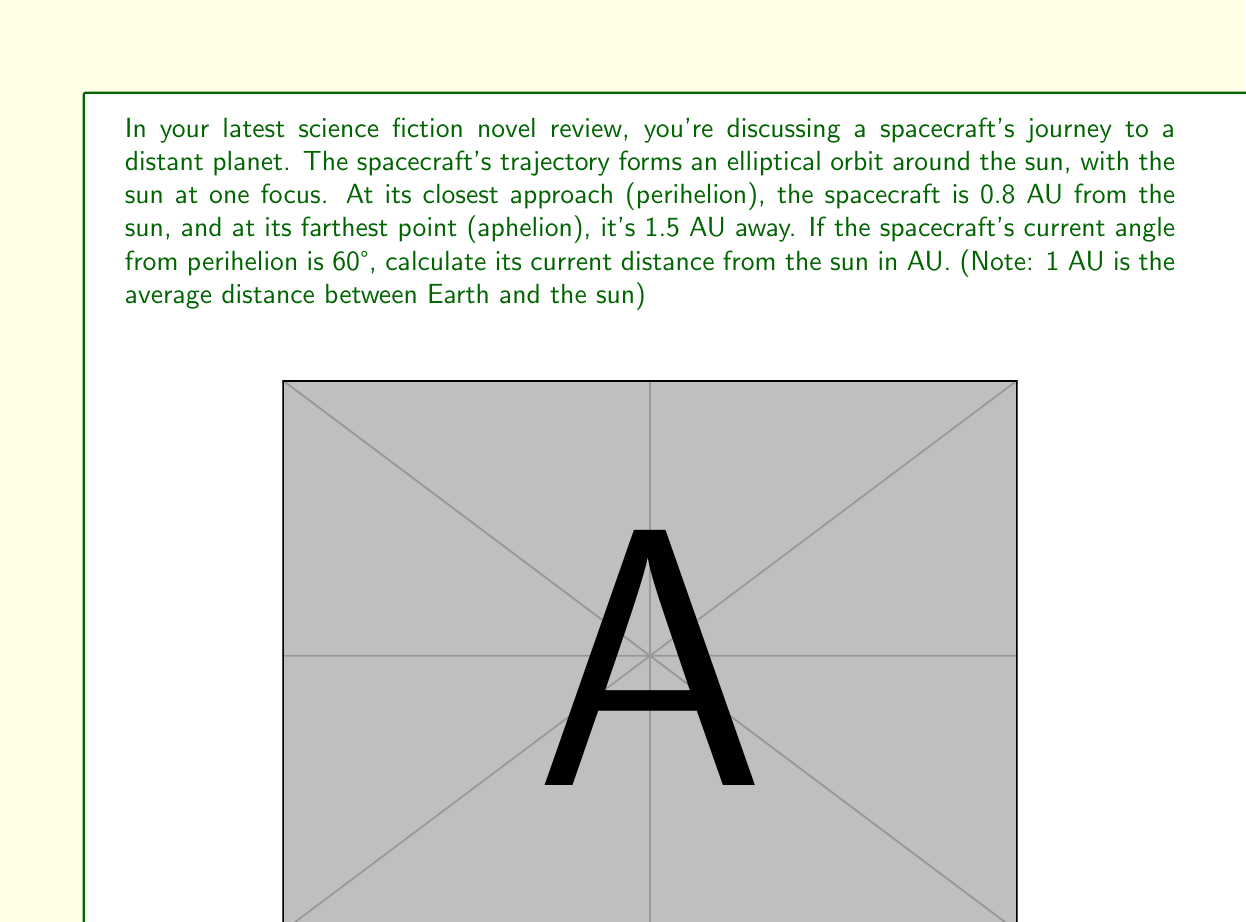Could you help me with this problem? To solve this problem, we'll use the polar equation of an ellipse:

$$r = \frac{a(1-e^2)}{1 + e \cos(\theta)}$$

Where:
$r$ is the distance from the focus (sun) to a point on the ellipse
$a$ is the semi-major axis
$e$ is the eccentricity
$\theta$ is the angle from perihelion

Step 1: Calculate the semi-major axis $(a)$
The semi-major axis is the average of the perihelion and aphelion distances:

$$a = \frac{0.8 + 1.5}{2} = 1.15 \text{ AU}$$

Step 2: Calculate the eccentricity $(e)$
The eccentricity can be found using the perihelion distance $(q)$ and the semi-major axis:

$$e = 1 - \frac{q}{a} = 1 - \frac{0.8}{1.15} \approx 0.3043$$

Step 3: Apply the polar equation of an ellipse
Now we can substitute our values into the equation:

$$r = \frac{1.15(1-0.3043^2)}{1 + 0.3043 \cos(60°)}$$

Step 4: Simplify and calculate
$$r = \frac{1.15(1-0.0926)}{1 + 0.3043 \cdot 0.5}$$
$$r = \frac{1.15 \cdot 0.9074}{1 + 0.1522}$$
$$r = \frac{1.0435}{1.1522}$$
$$r \approx 0.9057 \text{ AU}$$

Therefore, the spacecraft's current distance from the sun is approximately 0.9057 AU.
Answer: 0.9057 AU 